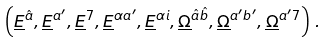<formula> <loc_0><loc_0><loc_500><loc_500>\left ( \underline { E } ^ { \hat { a } } , \underline { E } ^ { a ^ { \prime } } , \underline { E } ^ { 7 } , \underline { E } ^ { \alpha a ^ { \prime } } , \underline { E } ^ { \alpha i } , \underline { \Omega } ^ { \hat { a } \hat { b } } , \underline { \Omega } ^ { a ^ { \prime } b ^ { \prime } } , \underline { \Omega } ^ { a ^ { \prime } 7 } \right ) \, .</formula> 